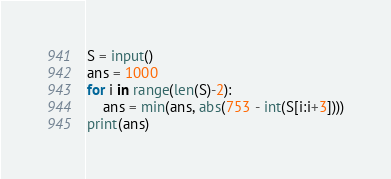Convert code to text. <code><loc_0><loc_0><loc_500><loc_500><_Python_>S = input()
ans = 1000
for i in range(len(S)-2):
    ans = min(ans, abs(753 - int(S[i:i+3])))
print(ans)
</code> 